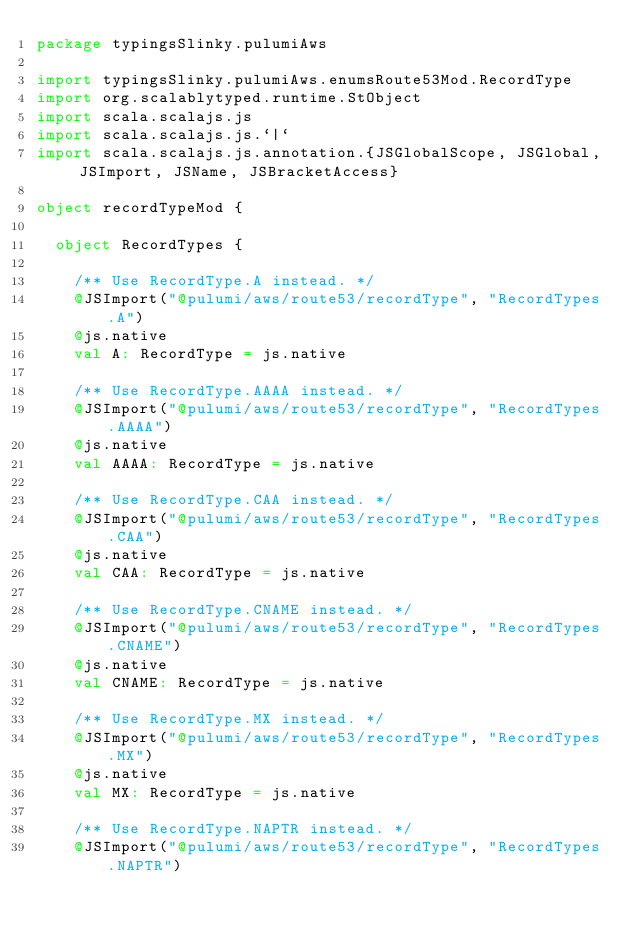Convert code to text. <code><loc_0><loc_0><loc_500><loc_500><_Scala_>package typingsSlinky.pulumiAws

import typingsSlinky.pulumiAws.enumsRoute53Mod.RecordType
import org.scalablytyped.runtime.StObject
import scala.scalajs.js
import scala.scalajs.js.`|`
import scala.scalajs.js.annotation.{JSGlobalScope, JSGlobal, JSImport, JSName, JSBracketAccess}

object recordTypeMod {
  
  object RecordTypes {
    
    /** Use RecordType.A instead. */
    @JSImport("@pulumi/aws/route53/recordType", "RecordTypes.A")
    @js.native
    val A: RecordType = js.native
    
    /** Use RecordType.AAAA instead. */
    @JSImport("@pulumi/aws/route53/recordType", "RecordTypes.AAAA")
    @js.native
    val AAAA: RecordType = js.native
    
    /** Use RecordType.CAA instead. */
    @JSImport("@pulumi/aws/route53/recordType", "RecordTypes.CAA")
    @js.native
    val CAA: RecordType = js.native
    
    /** Use RecordType.CNAME instead. */
    @JSImport("@pulumi/aws/route53/recordType", "RecordTypes.CNAME")
    @js.native
    val CNAME: RecordType = js.native
    
    /** Use RecordType.MX instead. */
    @JSImport("@pulumi/aws/route53/recordType", "RecordTypes.MX")
    @js.native
    val MX: RecordType = js.native
    
    /** Use RecordType.NAPTR instead. */
    @JSImport("@pulumi/aws/route53/recordType", "RecordTypes.NAPTR")</code> 